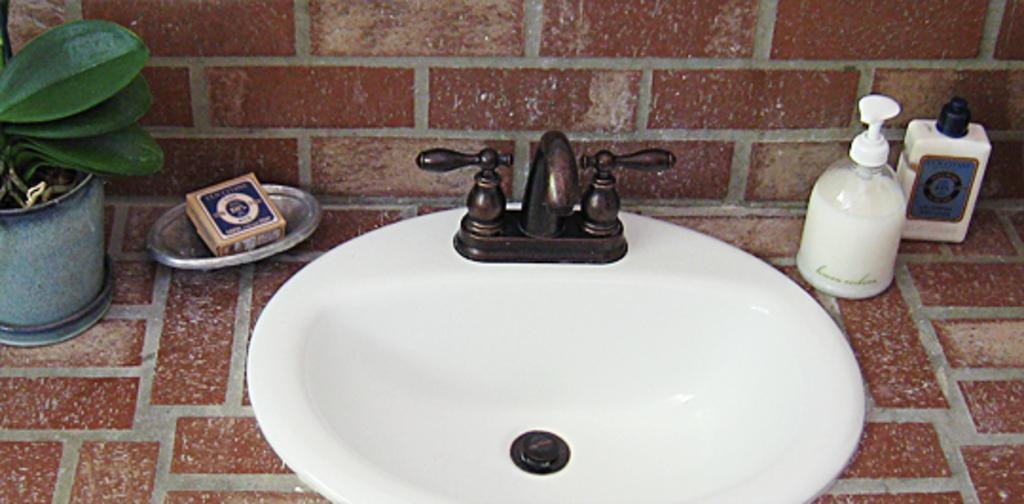What is the main object in the image? There is a washbasin in the image. What is attached to the washbasin? There is a tap in the image. What can be seen near the washbasin? There are bottles in the image. Where is the matchbox located in the image? The matchbox is on the soap tray in the image. What is present on the cabinet in the image? There is a plant on the cabinet in the image. What type of humor can be seen in the image? There is no humor present in the image; it is a scene featuring a washbasin, tap, bottles, matchbox, and plant. 